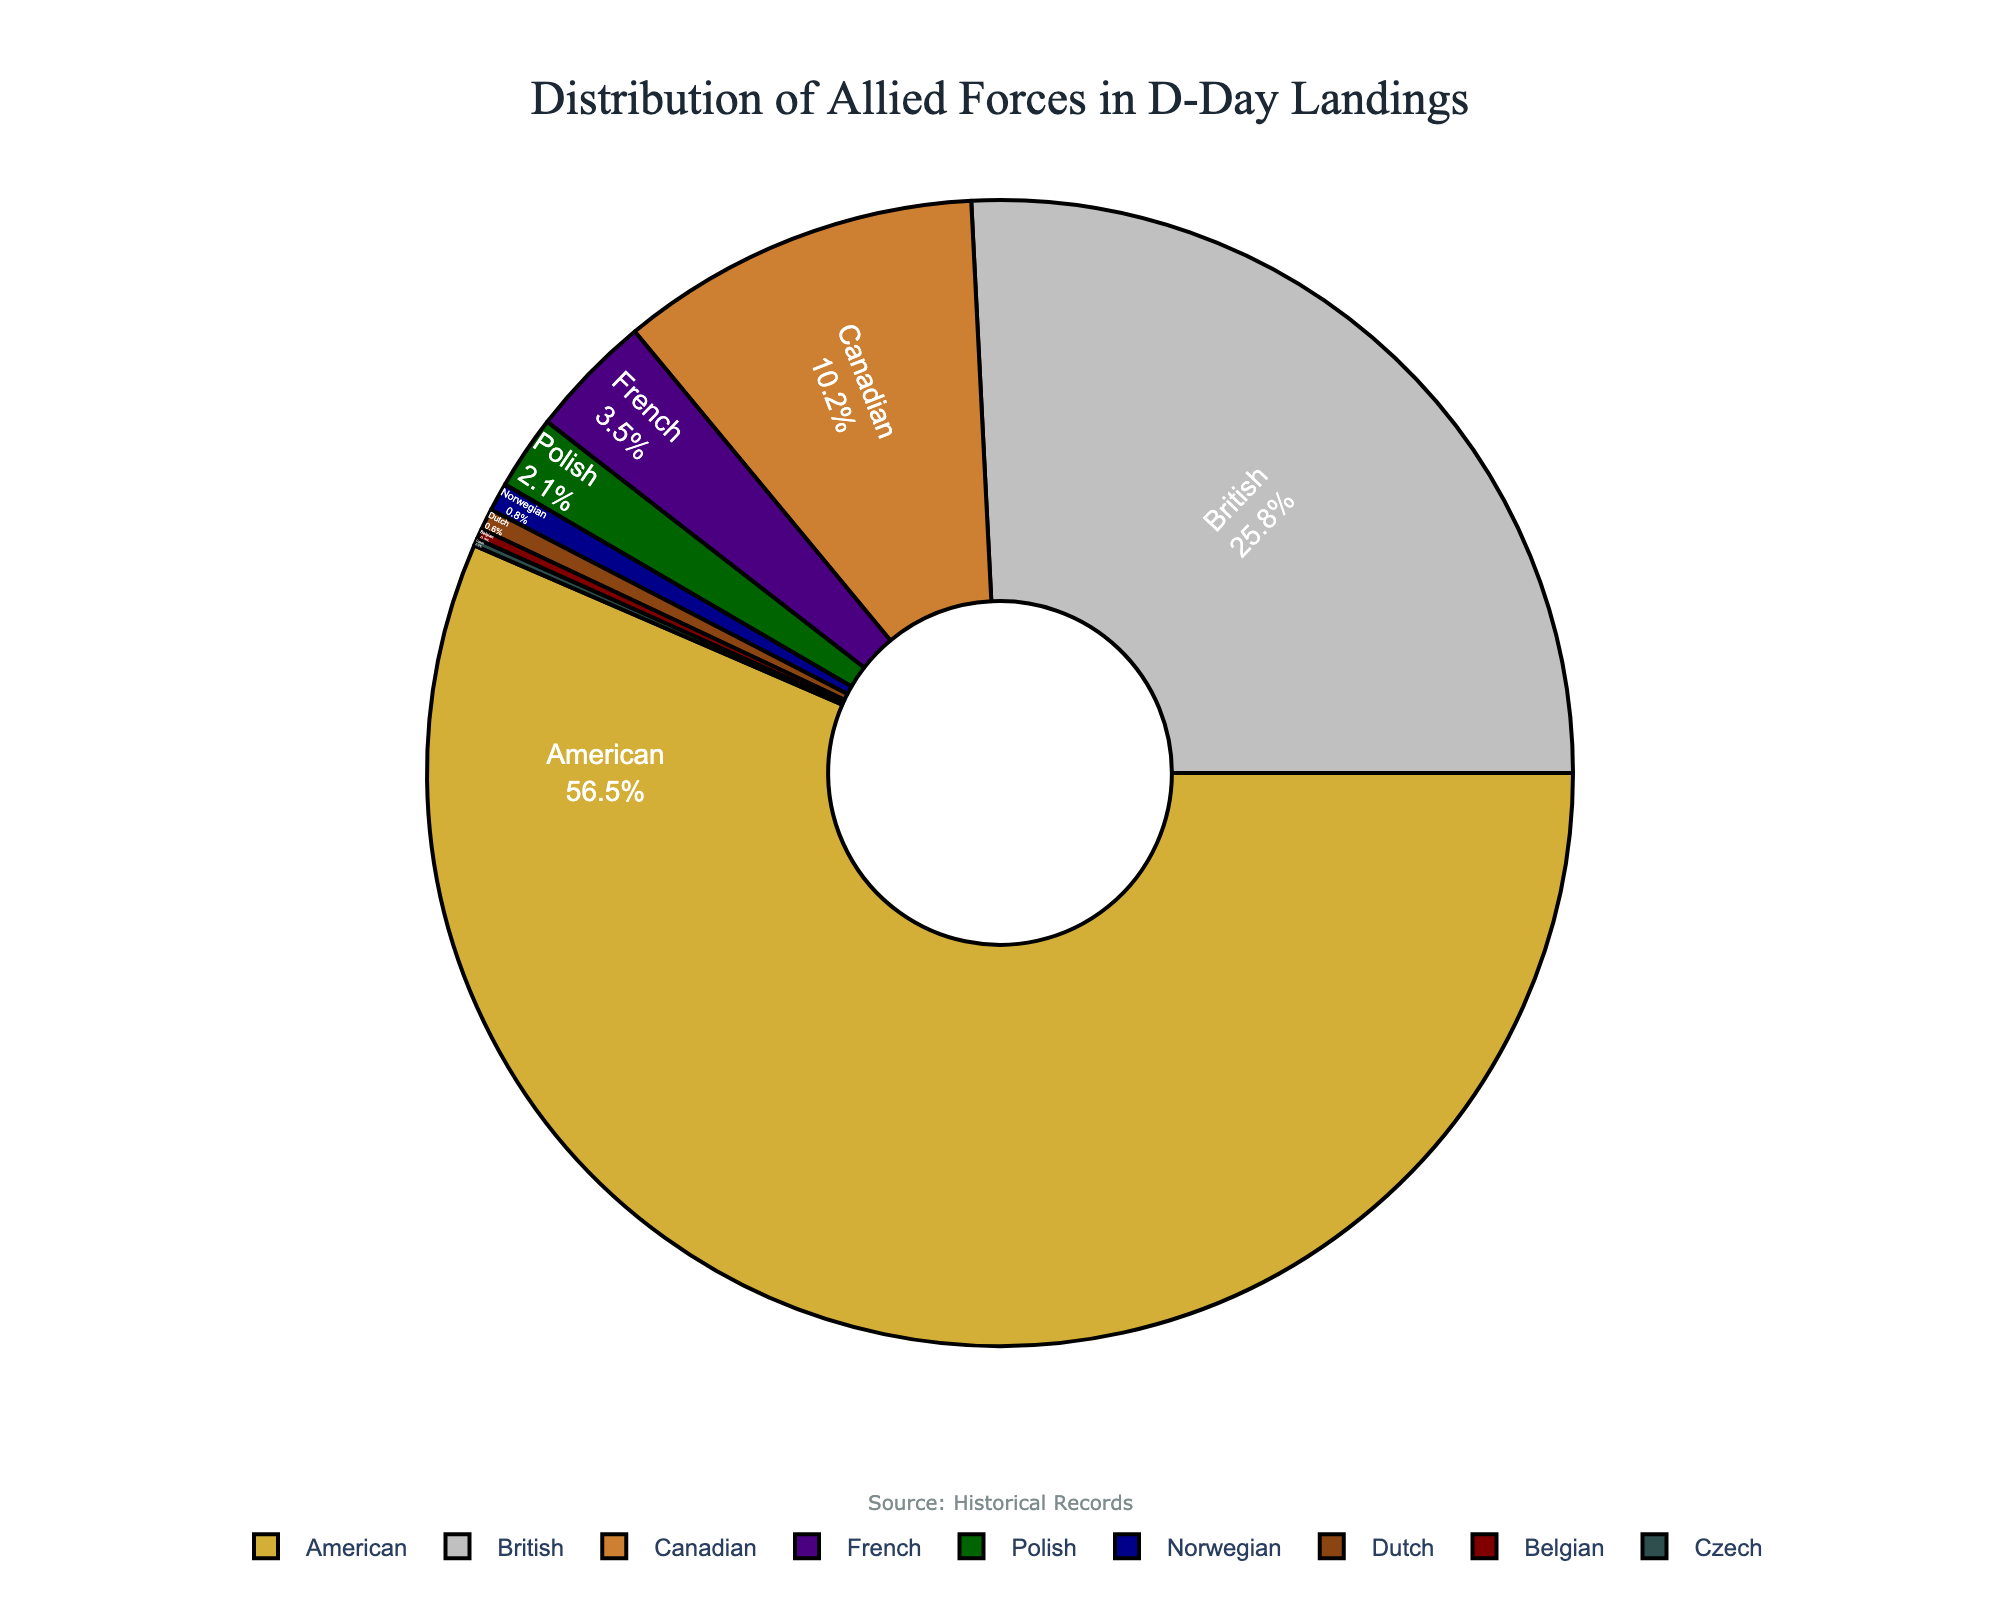How many nationalities are represented in the pie chart? To count the nationalities represented in the pie chart, refer to the labels, which show different nationalities contributing to the Allied forces. There are 9 slices in the pie chart.
Answer: 9 Which nationality contributed the smallest percentage to the D-Day landings? Reviewing the pie chart, the smallest segment is for the Czech nationality. The value next to 'Czech' shows a 0.2% contribution.
Answer: Czech What is the combined percentage of British and Canadian forces? To find the combined percentage, add the contributions of British and Canadian forces: 25.8% (British) + 10.2% (Canadian) = 36%.
Answer: 36% Which nationalities together make up more than 60% of the Allied forces? Locate the largest segments in the pie chart. Adding the American contribution (56.5%) and the next largest, British (25.8%), results in 56.5% + 25.8% = 82.3%. Both these nationalities together exceed 60%.
Answer: American, British Do the contributions from French, Polish, Norwegian, Dutch, Belgian, and Czech combined exceed 10%? Add their contributions: 3.5% (French) + 2.1% (Polish) + 0.8% (Norwegian) + 0.6% (Dutch) + 0.3% (Belgian) + 0.2% (Czech) = 7.5%. This total is less than 10%.
Answer: No Which nationality has a larger contribution, the French or the Polish? Compare the percentage contributions of the French (3.5%) and Polish (2.1%). The French contribution is larger.
Answer: French What is the difference in contribution between the Canadian and French forces? Subtract the French percentage from the Canadian percentage: 10.2% - 3.5% = 6.7%.
Answer: 6.7% Are the Belgian forces' contributions smaller or larger than the Norwegian forces? Compare the percentages: Belgian (0.3%) and Norwegian (0.8%). The Belgian contribution is smaller.
Answer: Smaller Which nationality appears in the darkest color on the pie chart? The segment representing the British nationality appears in the darkest color (dark blue) in the pie chart.
Answer: British What is the total contribution of the American, British, and Canadian forces combined? Add their contributions: 56.5% (American) + 25.8% (British) + 10.2% (Canadian) = 92.5%.
Answer: 92.5% 